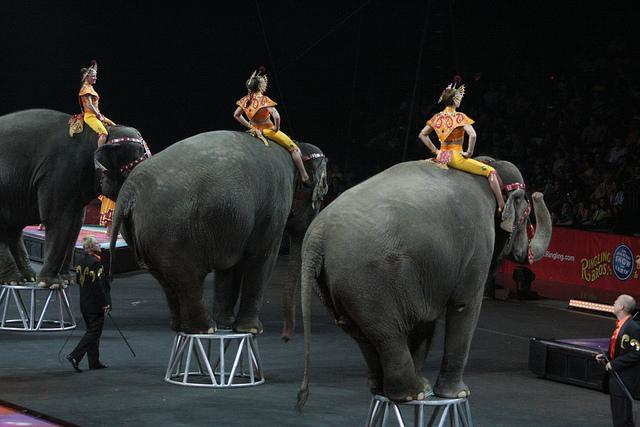What will the man do to the elephants with the sticks he holds? Please explain your reasoning. poke them. He will do this to tell them what to do next 